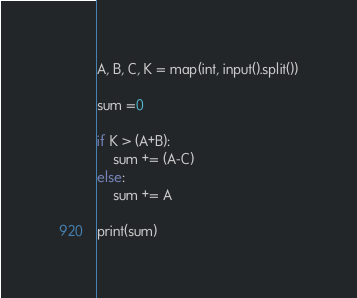Convert code to text. <code><loc_0><loc_0><loc_500><loc_500><_Python_>A, B, C, K = map(int, input().split())

sum =0

if K > (A+B):
    sum += (A-C)
else:
    sum += A
    
print(sum)</code> 